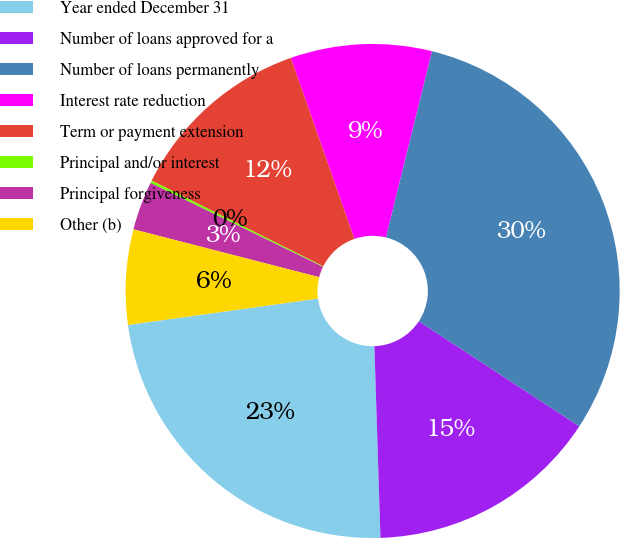Convert chart to OTSL. <chart><loc_0><loc_0><loc_500><loc_500><pie_chart><fcel>Year ended December 31<fcel>Number of loans approved for a<fcel>Number of loans permanently<fcel>Interest rate reduction<fcel>Term or payment extension<fcel>Principal and/or interest<fcel>Principal forgiveness<fcel>Other (b)<nl><fcel>23.31%<fcel>15.27%<fcel>30.37%<fcel>9.23%<fcel>12.25%<fcel>0.17%<fcel>3.19%<fcel>6.21%<nl></chart> 